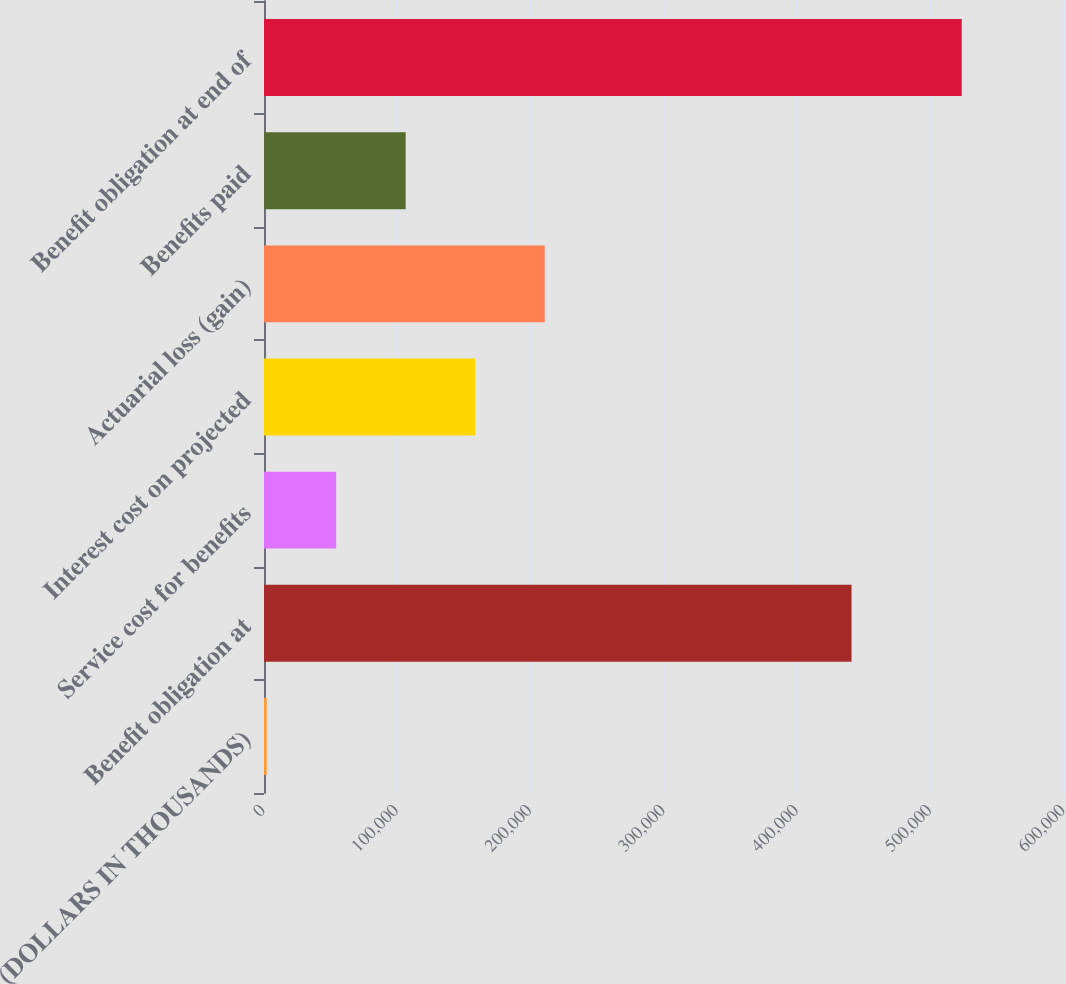<chart> <loc_0><loc_0><loc_500><loc_500><bar_chart><fcel>(DOLLARS IN THOUSANDS)<fcel>Benefit obligation at<fcel>Service cost for benefits<fcel>Interest cost on projected<fcel>Actuarial loss (gain)<fcel>Benefits paid<fcel>Benefit obligation at end of<nl><fcel>2011<fcel>440646<fcel>54139.7<fcel>158397<fcel>210526<fcel>106268<fcel>523298<nl></chart> 